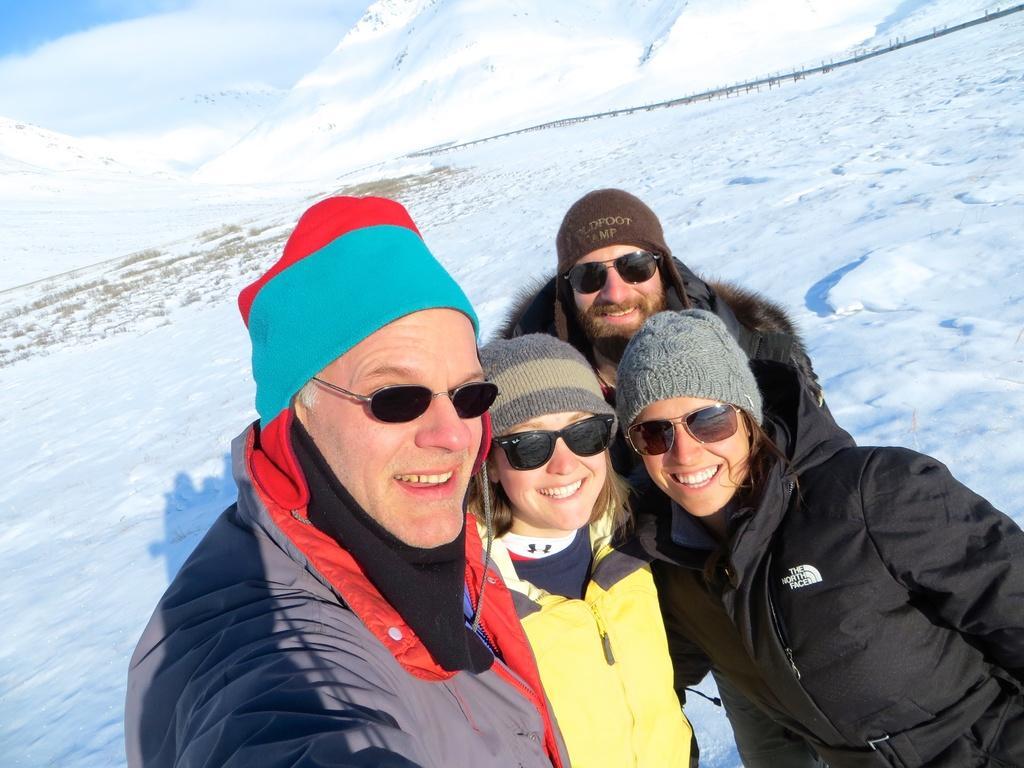Can you describe this image briefly? Here we can see people. These people are smiling, wore jackets, caps and goggles. Background we can see snow and sky. 